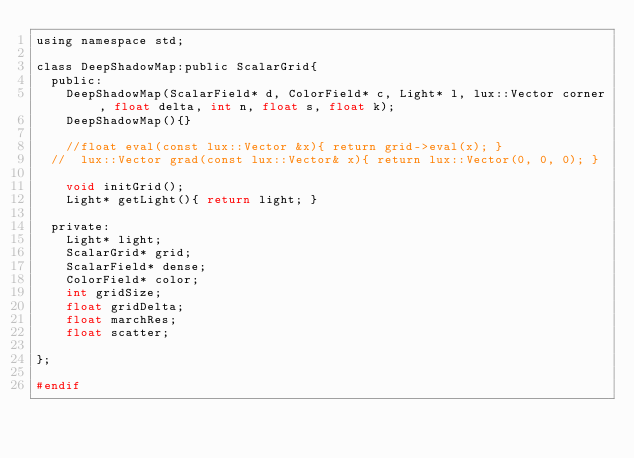<code> <loc_0><loc_0><loc_500><loc_500><_C_>using namespace std;

class DeepShadowMap:public ScalarGrid{
	public:
		DeepShadowMap(ScalarField* d, ColorField* c, Light* l, lux::Vector corner, float delta, int n, float s, float k);
		DeepShadowMap(){}

		//float eval(const lux::Vector &x){ return grid->eval(x); }
	//	lux::Vector grad(const lux::Vector& x){ return lux::Vector(0, 0, 0); }

		void initGrid();
		Light* getLight(){ return light; }

	private:
		Light* light;
		ScalarGrid* grid;
		ScalarField* dense;
		ColorField* color;
		int gridSize;
		float gridDelta; 
		float marchRes;
		float scatter;
		
};

#endif
</code> 